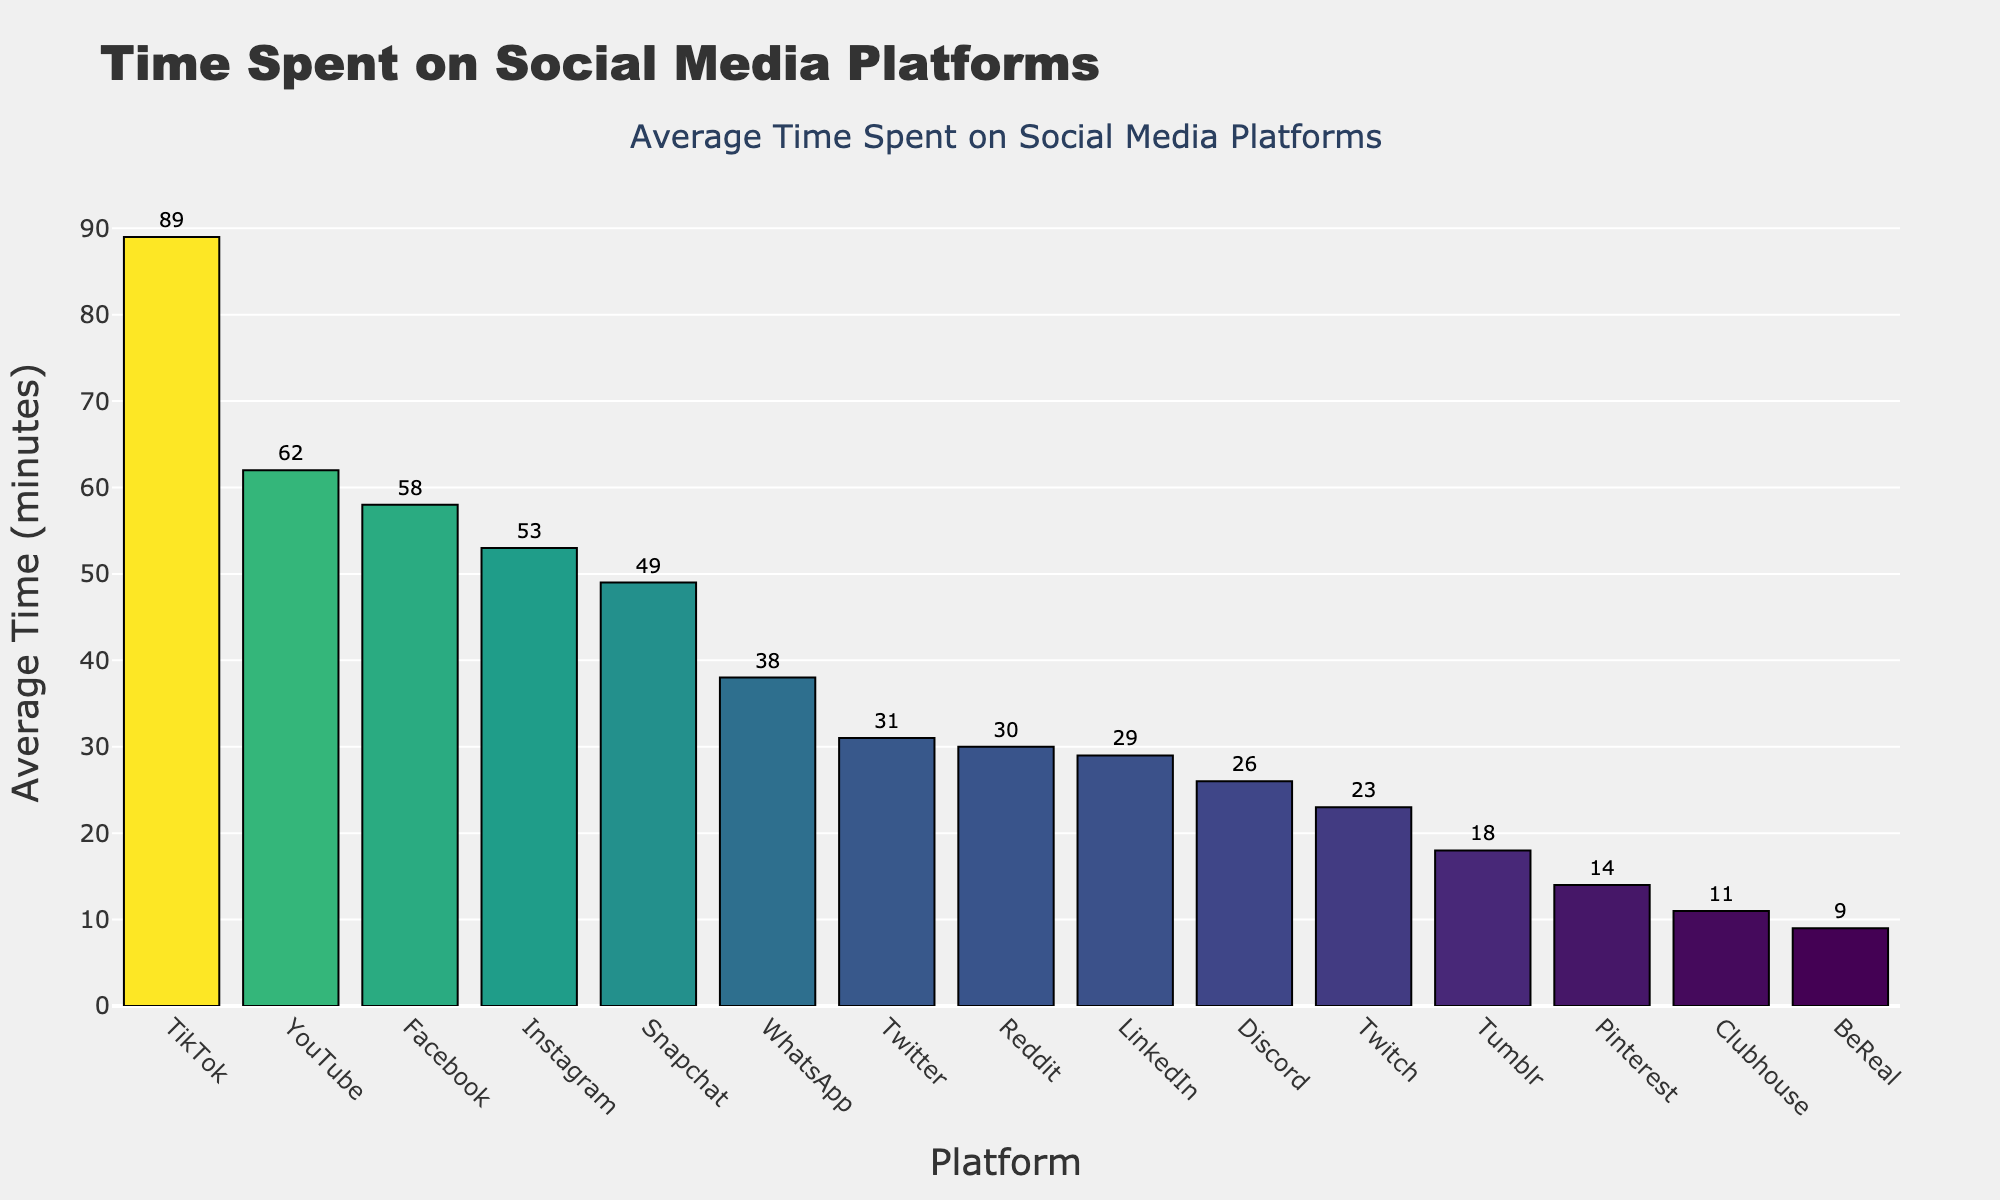What is the total average time spent per day on Facebook and Instagram combined? Add the average time spent on Facebook (58 minutes) and Instagram (53 minutes): 58 + 53 = 111 minutes
Answer: 111 minutes Which platform has the highest average time spent per day? The highest bar represents the platform with the highest average time spent, and it corresponds to TikTok at 89 minutes
Answer: TikTok How much more time do users spend on YouTube than on Pinterest per day on average? Subtract the average time spent on Pinterest (14 minutes) from the average time spent on YouTube (62 minutes): 62 - 14 = 48 minutes
Answer: 48 minutes Which two platforms have the closest average time spent per day, and what are their values? Compare the values and find the smallest difference between average times: Reddit (30 minutes) and LinkedIn (29 minutes) have a difference of 1 minute
Answer: Reddit (30 minutes) and LinkedIn (29 minutes) What is the median average time spent across all platforms? List the times in ascending order: 9, 11, 14, 18, 23, 26, 29, 30, 31, 38, 49, 53, 58, 62, 89. The median is the middle number, which is 31 minutes
Answer: 31 minutes Which platform is spent more time on, Snapchat or Twitter, and by how much? Compare the average time spent on Snapchat (49 minutes) and Twitter (31 minutes). Subtract the smaller value from the larger value: 49 - 31 = 18 minutes
Answer: Snapchat by 18 minutes Identify the platforms that have an average daily usage time below 20 minutes. Bars below the 20-minute mark correspond to platforms with average daily usage below 20 minutes: Clubhouse (11 minutes), BeReal (9 minutes), Pinterest (14 minutes), Tumblr (18 minutes)
Answer: Clubhouse, BeReal, Pinterest, Tumblr What is the range of average time spent across all platforms? Subtract the smallest value (9 minutes for BeReal) from the largest value (89 minutes for TikTok): 89 - 9 = 80 minutes
Answer: 80 minutes How does the time spent on WhatsApp compare to the average time spent on LinkedIn and Reddit combined? Calculate the combined time for LinkedIn and Reddit: 29 + 30 = 59 minutes. Compare this to WhatsApp's time (38 minutes)
Answer: WhatsApp is 21 minutes less 